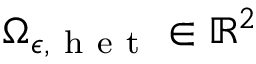<formula> <loc_0><loc_0><loc_500><loc_500>{ \Omega } _ { \epsilon , h e t } \in \mathbb { R } ^ { 2 }</formula> 